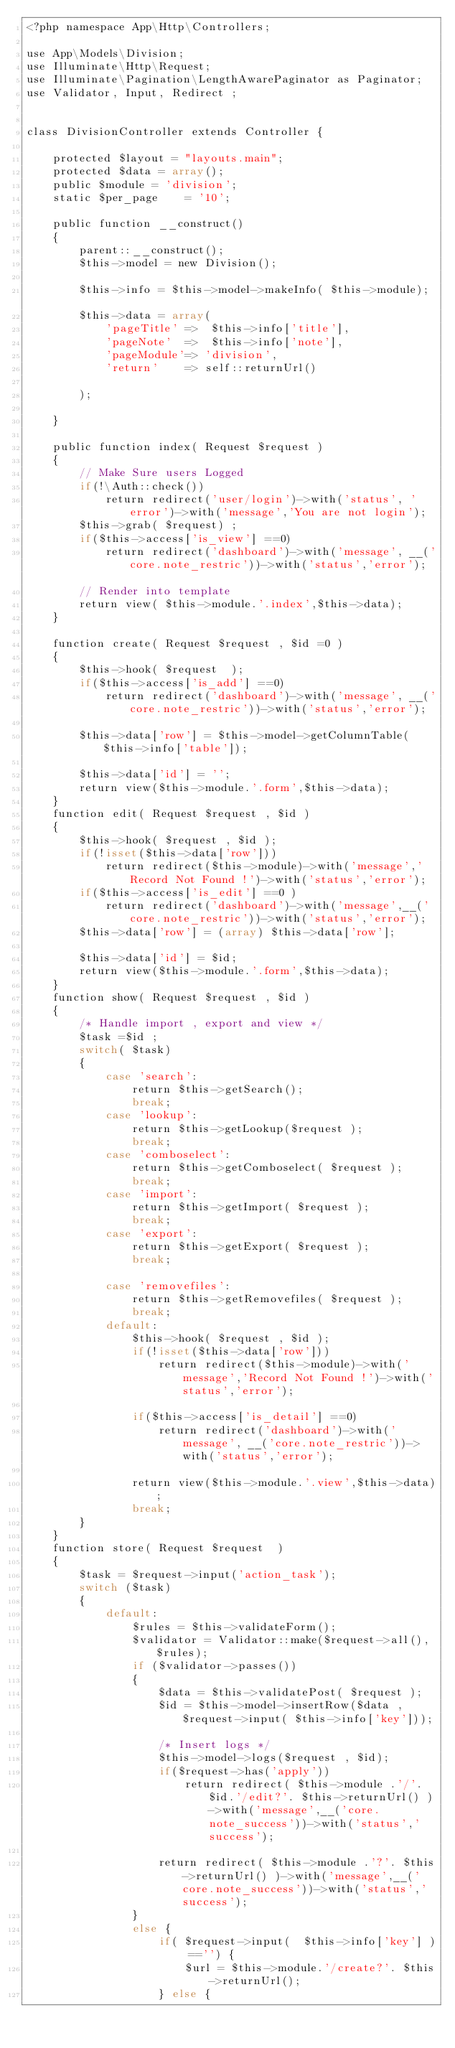Convert code to text. <code><loc_0><loc_0><loc_500><loc_500><_PHP_><?php namespace App\Http\Controllers;

use App\Models\Division;
use Illuminate\Http\Request;
use Illuminate\Pagination\LengthAwarePaginator as Paginator;
use Validator, Input, Redirect ; 


class DivisionController extends Controller {

	protected $layout = "layouts.main";
	protected $data = array();	
	public $module = 'division';
	static $per_page	= '10';

	public function __construct()
	{		
		parent::__construct();
		$this->model = new Division();	
		
		$this->info = $this->model->makeInfo( $this->module);	
		$this->data = array(
			'pageTitle'	=> 	$this->info['title'],
			'pageNote'	=>  $this->info['note'],
			'pageModule'=> 'division',
			'return'	=> self::returnUrl()
			
		);
		
	}

	public function index( Request $request )
	{
		// Make Sure users Logged 
		if(!\Auth::check()) 
			return redirect('user/login')->with('status', 'error')->with('message','You are not login');
		$this->grab( $request) ;
		if($this->access['is_view'] ==0) 
			return redirect('dashboard')->with('message', __('core.note_restric'))->with('status','error');				
		// Render into template
		return view( $this->module.'.index',$this->data);
	}	

	function create( Request $request , $id =0 ) 
	{
		$this->hook( $request  );
		if($this->access['is_add'] ==0) 
			return redirect('dashboard')->with('message', __('core.note_restric'))->with('status','error');

		$this->data['row'] = $this->model->getColumnTable( $this->info['table']); 
		
		$this->data['id'] = '';
		return view($this->module.'.form',$this->data);
	}
	function edit( Request $request , $id ) 
	{
		$this->hook( $request , $id );
		if(!isset($this->data['row']))
			return redirect($this->module)->with('message','Record Not Found !')->with('status','error');
		if($this->access['is_edit'] ==0 )
			return redirect('dashboard')->with('message',__('core.note_restric'))->with('status','error');
		$this->data['row'] = (array) $this->data['row'];
		
		$this->data['id'] = $id;
		return view($this->module.'.form',$this->data);
	}	
	function show( Request $request , $id ) 
	{
		/* Handle import , export and view */
		$task =$id ;
		switch( $task)
		{
			case 'search':
				return $this->getSearch();
				break;
			case 'lookup':
				return $this->getLookup($request );
				break;
			case 'comboselect':
				return $this->getComboselect( $request );
				break;
			case 'import':
				return $this->getImport( $request );
				break;
			case 'export':
				return $this->getExport( $request );
				break;

			case 'removefiles':
				return $this->getRemovefiles( $request );
				break;	
			default:
				$this->hook( $request , $id );
				if(!isset($this->data['row']))
					return redirect($this->module)->with('message','Record Not Found !')->with('status','error');

				if($this->access['is_detail'] ==0) 
					return redirect('dashboard')->with('message', __('core.note_restric'))->with('status','error');

				return view($this->module.'.view',$this->data);	
				break;		
		}
	}
	function store( Request $request  )
	{
		$task = $request->input('action_task');
		switch ($task)
		{
			default:
				$rules = $this->validateForm();
				$validator = Validator::make($request->all(), $rules);
				if ($validator->passes()) 
				{
					$data = $this->validatePost( $request );
					$id = $this->model->insertRow($data , $request->input( $this->info['key']));
					
					/* Insert logs */
					$this->model->logs($request , $id);
					if($request->has('apply'))
						return redirect( $this->module .'/'.$id.'/edit?'. $this->returnUrl() )->with('message',__('core.note_success'))->with('status','success');

					return redirect( $this->module .'?'. $this->returnUrl() )->with('message',__('core.note_success'))->with('status','success');
				} 
				else {
					if( $request->input(  $this->info['key'] ) =='') {
						$url = $this->module.'/create?'. $this->returnUrl();
					} else {</code> 